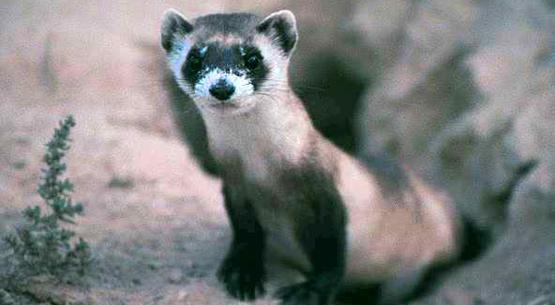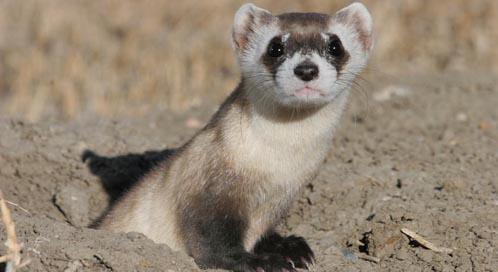The first image is the image on the left, the second image is the image on the right. Given the left and right images, does the statement "A ferret is partially underground." hold true? Answer yes or no. Yes. 